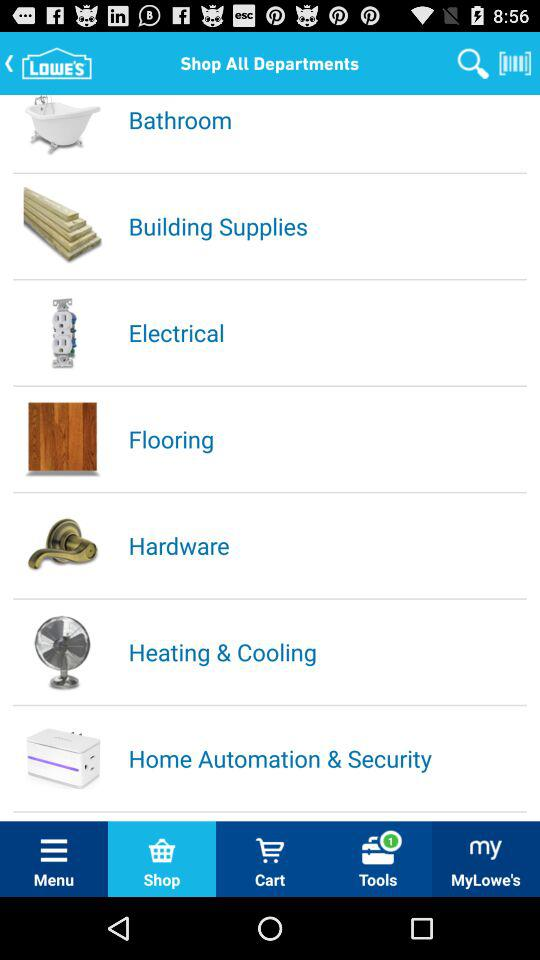Which tab is selected? The selected tab is "Shop". 